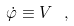Convert formula to latex. <formula><loc_0><loc_0><loc_500><loc_500>\dot { \varphi } \equiv V \ ,</formula> 